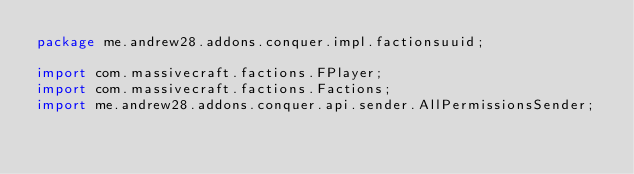<code> <loc_0><loc_0><loc_500><loc_500><_Java_>package me.andrew28.addons.conquer.impl.factionsuuid;

import com.massivecraft.factions.FPlayer;
import com.massivecraft.factions.Factions;
import me.andrew28.addons.conquer.api.sender.AllPermissionsSender;</code> 